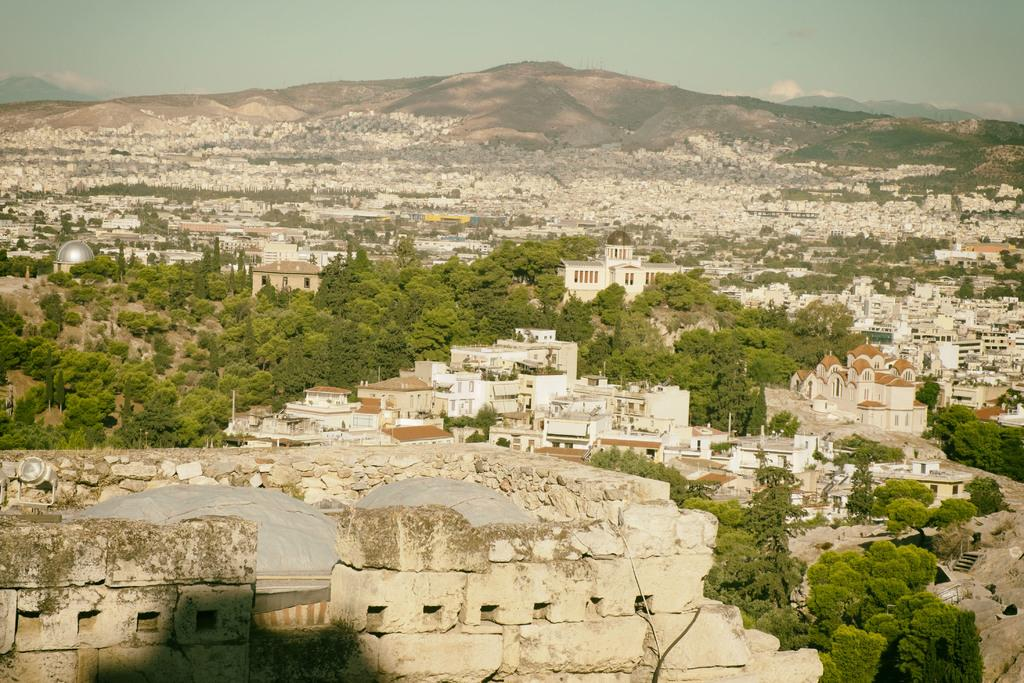What can be seen in the foreground of the image? There are many buildings and trees in the foreground of the image. What is located in the background of the image? There is a mountain in the background of the image. What is visible in the sky in the image? The sky is visible in the image, and there is a cloud present. What type of beam is holding up the mountain in the image? There is no beam present in the image; the mountain is a natural formation and does not require any support. Can you tell me which aunt is standing next to the trees in the image? There is no aunt present in the image; the facts provided do not mention any people. 